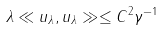<formula> <loc_0><loc_0><loc_500><loc_500>\lambda \ll u _ { \lambda } , u _ { \lambda } \gg \leq C ^ { 2 } \gamma ^ { - 1 }</formula> 